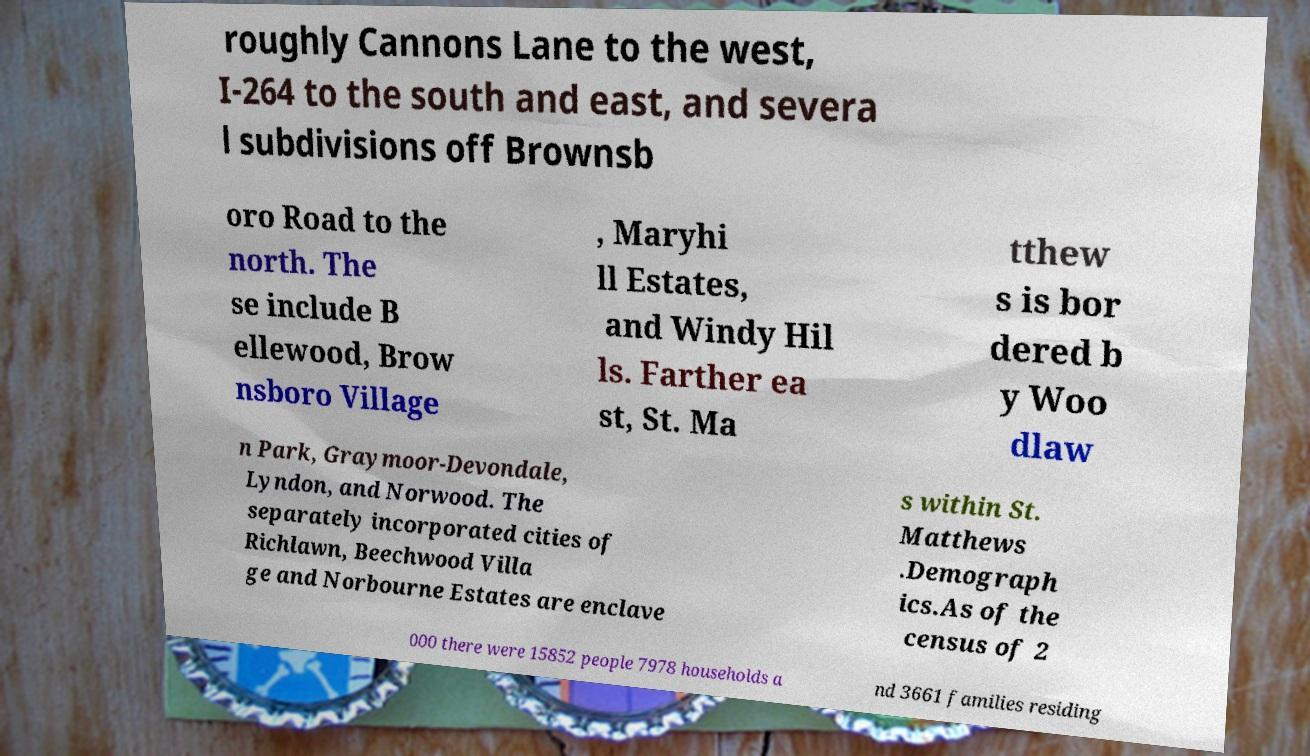What messages or text are displayed in this image? I need them in a readable, typed format. roughly Cannons Lane to the west, I-264 to the south and east, and severa l subdivisions off Brownsb oro Road to the north. The se include B ellewood, Brow nsboro Village , Maryhi ll Estates, and Windy Hil ls. Farther ea st, St. Ma tthew s is bor dered b y Woo dlaw n Park, Graymoor-Devondale, Lyndon, and Norwood. The separately incorporated cities of Richlawn, Beechwood Villa ge and Norbourne Estates are enclave s within St. Matthews .Demograph ics.As of the census of 2 000 there were 15852 people 7978 households a nd 3661 families residing 